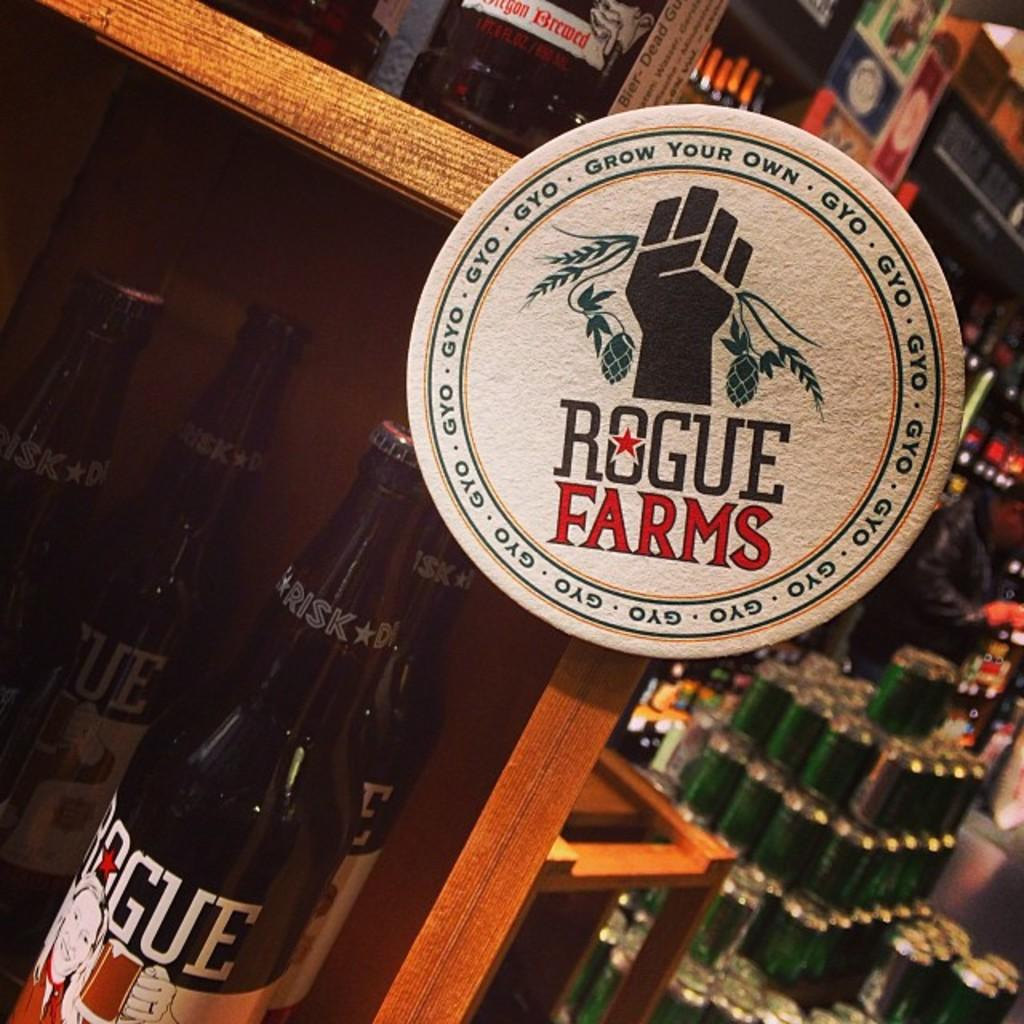<image>
Provide a brief description of the given image. Bottle of Rogue Farm beer in front of some other alcohol. 